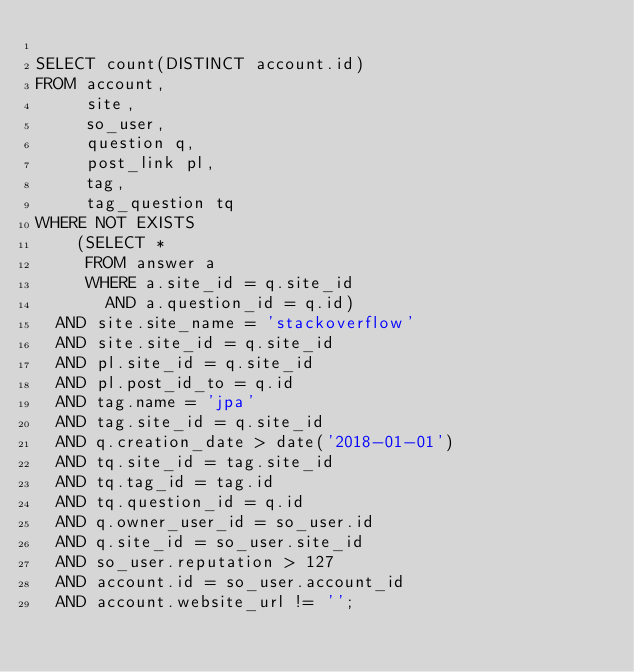<code> <loc_0><loc_0><loc_500><loc_500><_SQL_>
SELECT count(DISTINCT account.id)
FROM account,
     site,
     so_user,
     question q,
     post_link pl,
     tag,
     tag_question tq
WHERE NOT EXISTS
    (SELECT *
     FROM answer a
     WHERE a.site_id = q.site_id
       AND a.question_id = q.id)
  AND site.site_name = 'stackoverflow'
  AND site.site_id = q.site_id
  AND pl.site_id = q.site_id
  AND pl.post_id_to = q.id
  AND tag.name = 'jpa'
  AND tag.site_id = q.site_id
  AND q.creation_date > date('2018-01-01')
  AND tq.site_id = tag.site_id
  AND tq.tag_id = tag.id
  AND tq.question_id = q.id
  AND q.owner_user_id = so_user.id
  AND q.site_id = so_user.site_id
  AND so_user.reputation > 127
  AND account.id = so_user.account_id
  AND account.website_url != '';</code> 